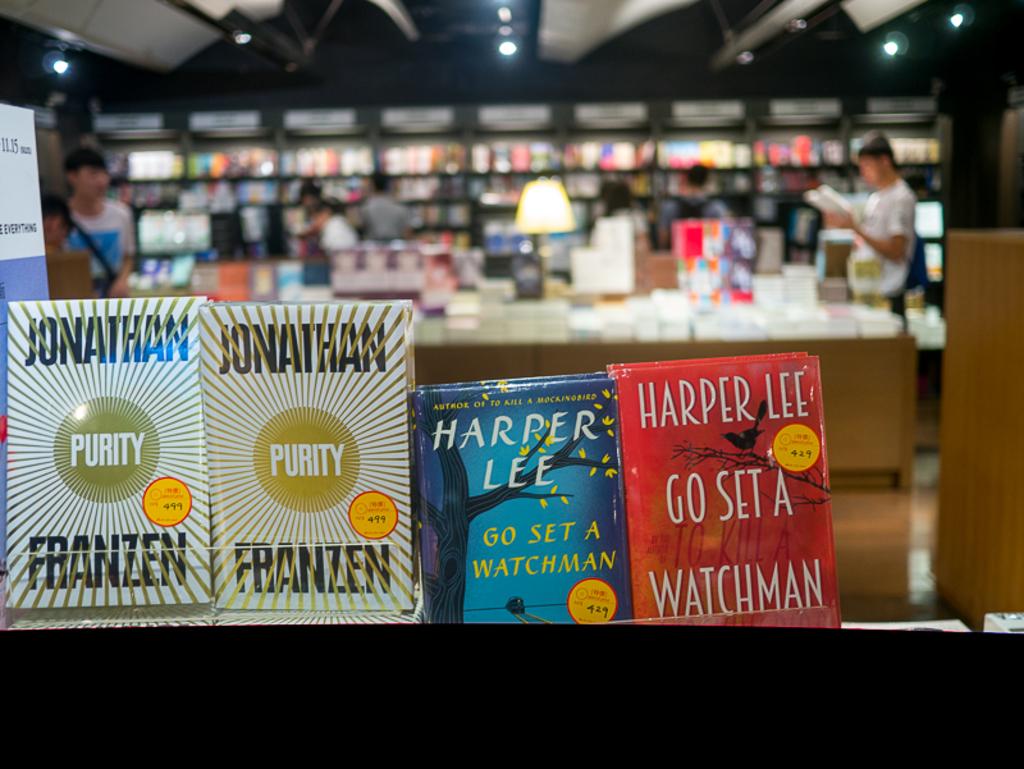Who is the publisher of the red book?
Ensure brevity in your answer.  Harper lee. 